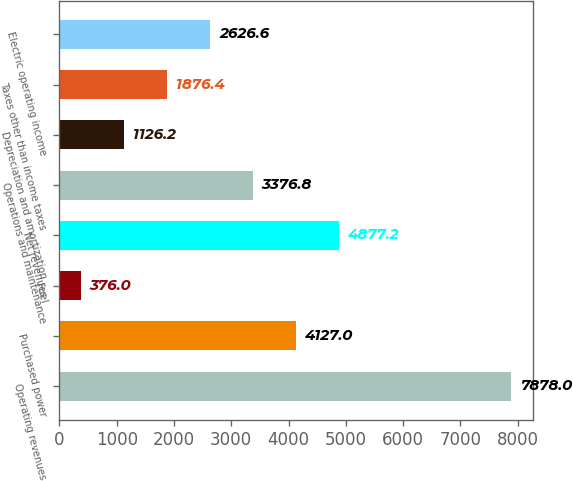Convert chart to OTSL. <chart><loc_0><loc_0><loc_500><loc_500><bar_chart><fcel>Operating revenues<fcel>Purchased power<fcel>Fuel<fcel>Net revenues<fcel>Operations and maintenance<fcel>Depreciation and amortization<fcel>Taxes other than income taxes<fcel>Electric operating income<nl><fcel>7878<fcel>4127<fcel>376<fcel>4877.2<fcel>3376.8<fcel>1126.2<fcel>1876.4<fcel>2626.6<nl></chart> 